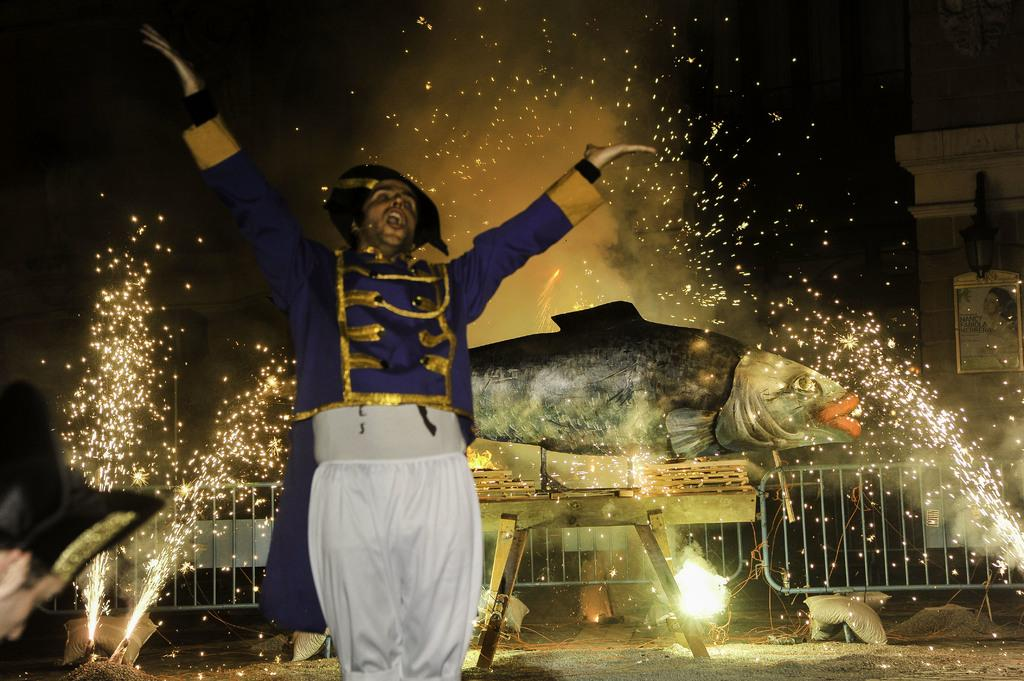Who is the main subject in the foreground of the image? There is a man in the foreground of the image. What can be seen in the background of the image? There is a model of a fish and sparkles in the background. Are there any other objects present in the background? Yes, there are other objects in the background. What type of bomb can be seen in the image? There is no bomb present in the image. What color is the copper in the image? There is no copper present in the image. 